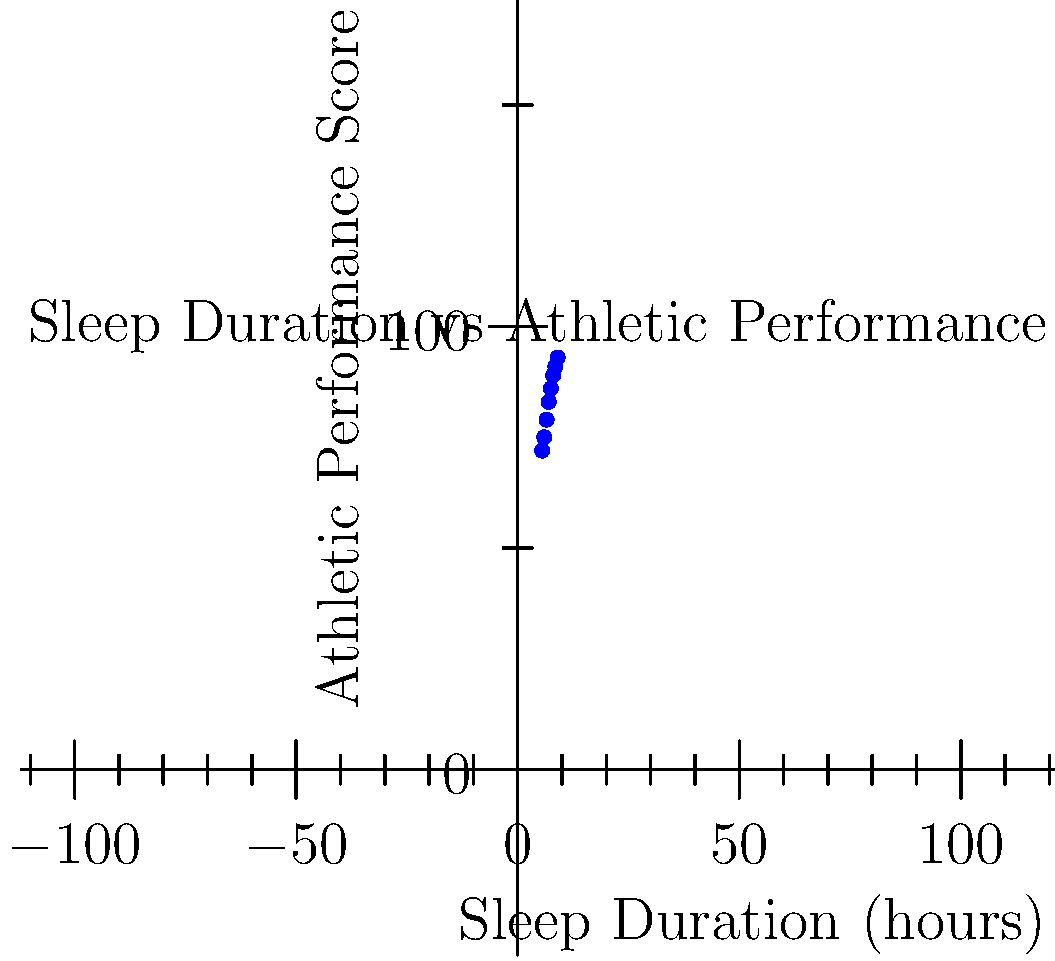Based on the scatter plot, what can be inferred about the relationship between sleep duration and athletic performance for professional athletes? To interpret the scatter plot and understand the relationship between sleep duration and athletic performance, let's follow these steps:

1. Observe the overall trend:
   The data points show a clear upward trend from left to right.

2. Analyze the correlation:
   There is a strong positive correlation between sleep duration and athletic performance score.

3. Interpret the best-fit line:
   The red line represents the best-fit line, which shows a linear relationship between the two variables.

4. Examine the range of data:
   Sleep duration ranges from about 5.5 to 9 hours, while performance scores range from about 72 to 93.

5. Note the consistency:
   The data points are relatively close to the best-fit line, indicating a consistent relationship.

6. Consider the slope:
   The steep positive slope of the best-fit line suggests that each additional hour of sleep is associated with a significant increase in athletic performance.

7. Evaluate practical implications:
   For professional athletes, increasing sleep duration appears to be associated with improved athletic performance scores.

8. Recognize limitations:
   While there is a strong correlation, this plot doesn't prove causation. Other factors may also influence athletic performance.

Given these observations, we can infer that there is a strong positive relationship between sleep duration and athletic performance for professional athletes, with longer sleep durations associated with higher performance scores.
Answer: Strong positive correlation; longer sleep associated with better athletic performance. 